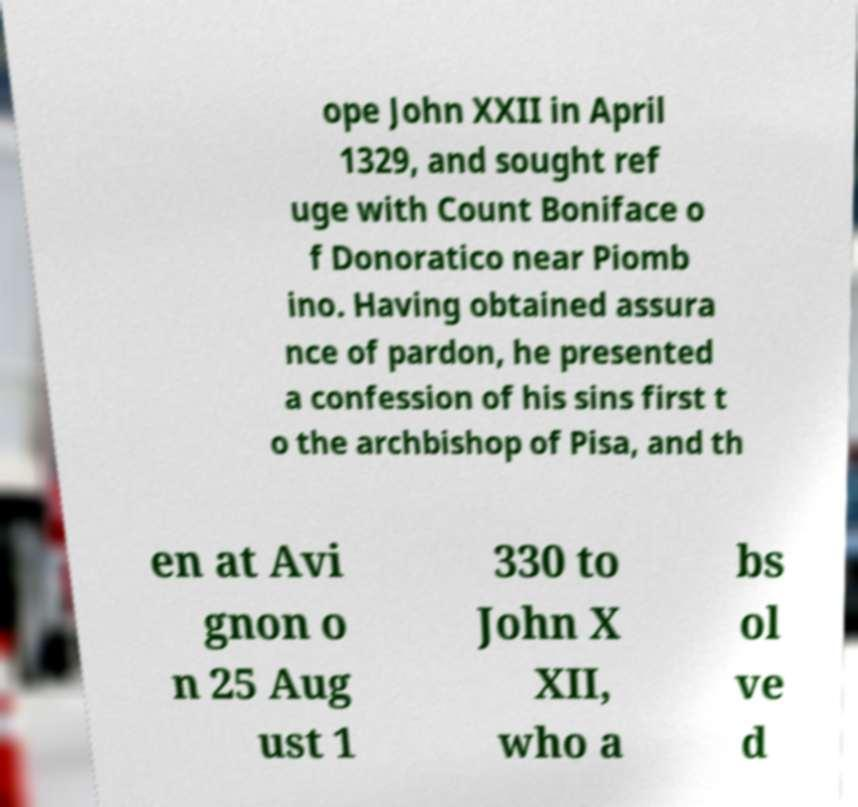Could you extract and type out the text from this image? ope John XXII in April 1329, and sought ref uge with Count Boniface o f Donoratico near Piomb ino. Having obtained assura nce of pardon, he presented a confession of his sins first t o the archbishop of Pisa, and th en at Avi gnon o n 25 Aug ust 1 330 to John X XII, who a bs ol ve d 